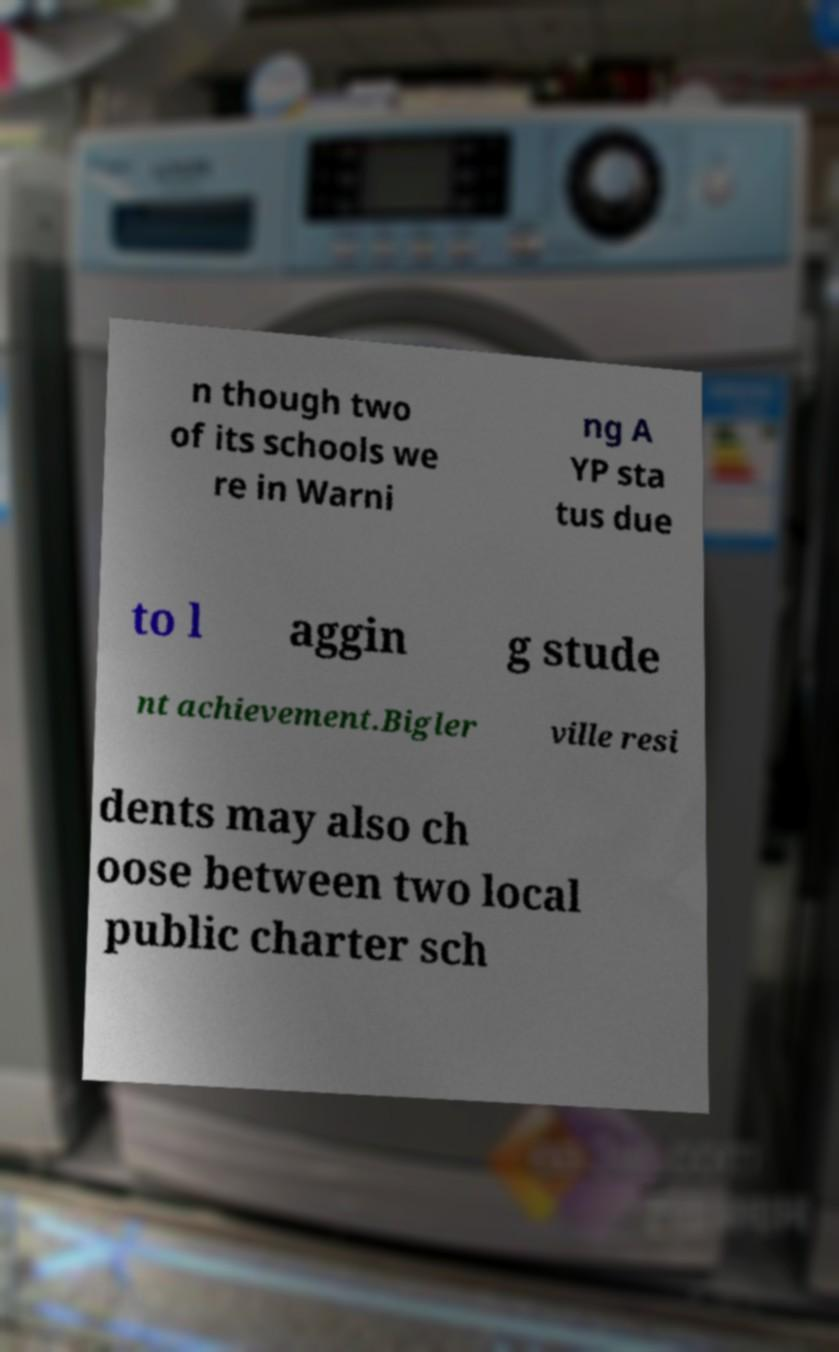Can you accurately transcribe the text from the provided image for me? n though two of its schools we re in Warni ng A YP sta tus due to l aggin g stude nt achievement.Bigler ville resi dents may also ch oose between two local public charter sch 